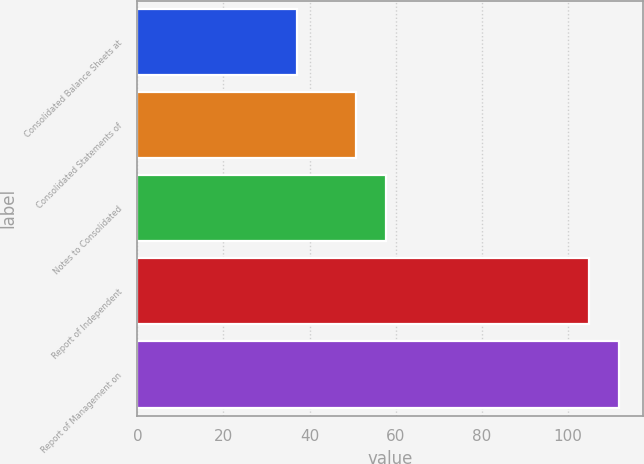Convert chart to OTSL. <chart><loc_0><loc_0><loc_500><loc_500><bar_chart><fcel>Consolidated Balance Sheets at<fcel>Consolidated Statements of<fcel>Notes to Consolidated<fcel>Report of Independent<fcel>Report of Management on<nl><fcel>37<fcel>50.8<fcel>57.7<fcel>105<fcel>111.9<nl></chart> 